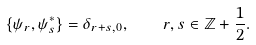<formula> <loc_0><loc_0><loc_500><loc_500>\{ \psi _ { r } , \psi _ { s } ^ { * } \} = \delta _ { r + s , 0 } , \quad r , s \in { \mathbb { Z } } + \frac { 1 } { 2 } .</formula> 